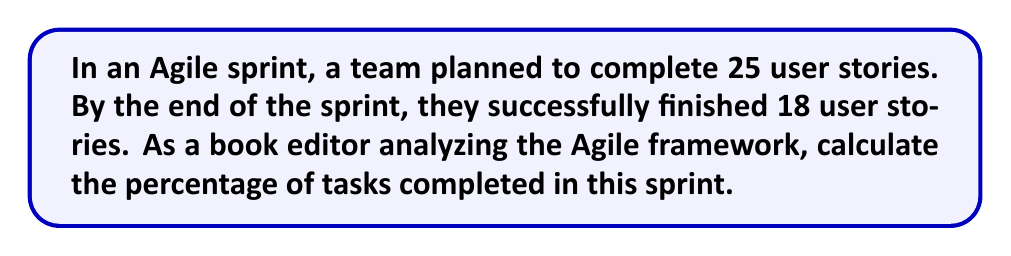Solve this math problem. To calculate the percentage of tasks completed in the sprint, we need to follow these steps:

1. Identify the total number of planned tasks:
   Total planned tasks = 25 user stories

2. Identify the number of completed tasks:
   Completed tasks = 18 user stories

3. Use the formula for percentage:
   $$ \text{Percentage} = \frac{\text{Completed tasks}}{\text{Total planned tasks}} \times 100\% $$

4. Plug in the values:
   $$ \text{Percentage} = \frac{18}{25} \times 100\% $$

5. Perform the division:
   $$ \text{Percentage} = 0.72 \times 100\% $$

6. Calculate the final percentage:
   $$ \text{Percentage} = 72\% $$

Therefore, the team completed 72% of the planned tasks in this sprint.
Answer: 72% 